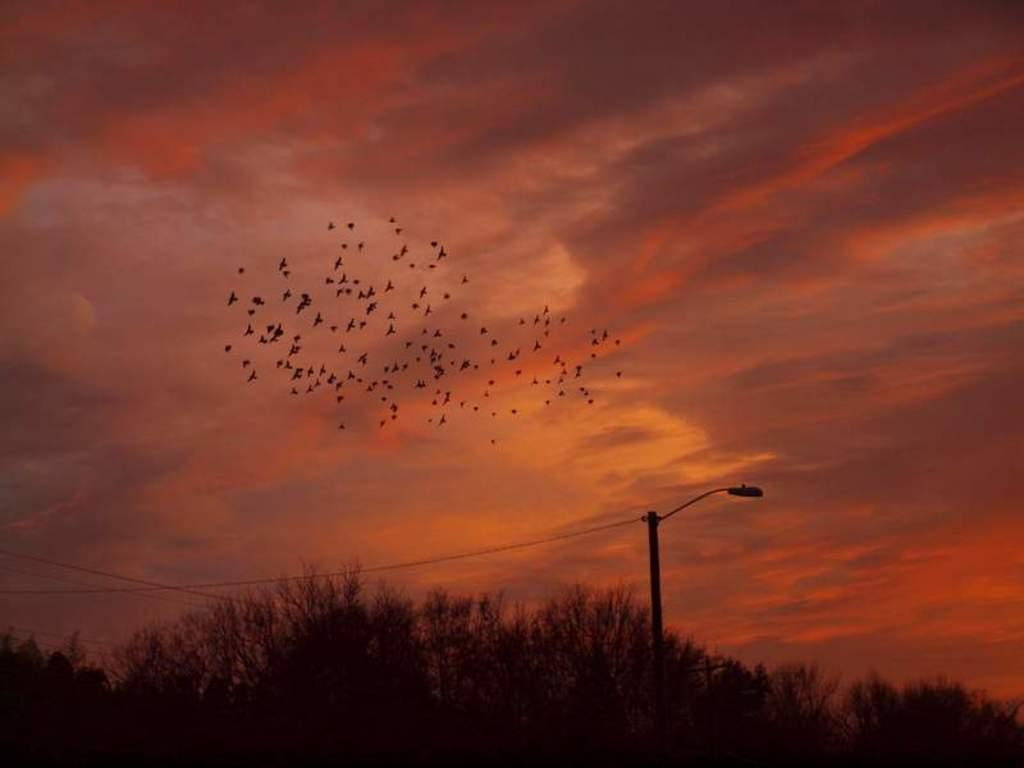What type of vegetation can be seen in the image? There are trees in the image. What structure is present in the image? There is a light pole in the image. What else can be seen in the image besides trees and the light pole? There are wires in the image. What is visible at the top of the image? The sky is visible at the top of the image. What is happening in the sky in the image? Birds are flying in the sky. What type of hole can be seen in the image? There is no hole present in the image. What season is depicted in the image? The provided facts do not specify the season, so it cannot be determined from the image. 